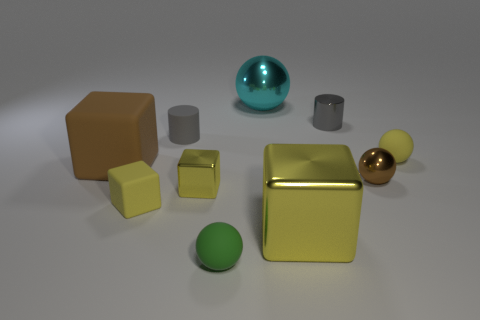Subtract all yellow spheres. How many yellow blocks are left? 3 Subtract 1 spheres. How many spheres are left? 3 Subtract all gray spheres. Subtract all brown cubes. How many spheres are left? 4 Subtract all cubes. How many objects are left? 6 Add 7 big yellow metallic objects. How many big yellow metallic objects are left? 8 Add 1 large cyan metal cylinders. How many large cyan metal cylinders exist? 1 Subtract 0 green blocks. How many objects are left? 10 Subtract all large green metal things. Subtract all spheres. How many objects are left? 6 